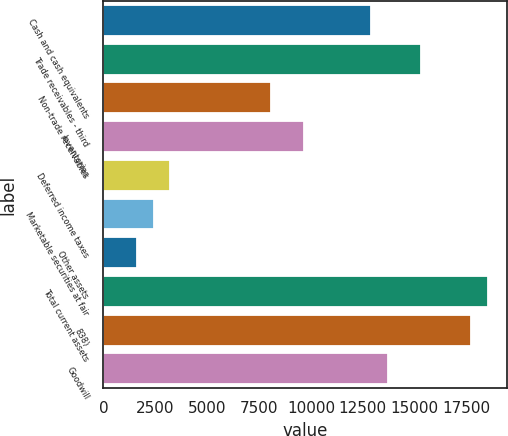Convert chart to OTSL. <chart><loc_0><loc_0><loc_500><loc_500><bar_chart><fcel>Cash and cash equivalents<fcel>Trade receivables - third<fcel>Non-trade receivables<fcel>Inventories<fcel>Deferred income taxes<fcel>Marketable securities at fair<fcel>Other assets<fcel>Total current assets<fcel>838)<fcel>Goodwill<nl><fcel>12889.8<fcel>15305.7<fcel>8058<fcel>9668.6<fcel>3226.2<fcel>2420.9<fcel>1615.6<fcel>18526.9<fcel>17721.6<fcel>13695.1<nl></chart> 